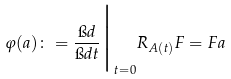Convert formula to latex. <formula><loc_0><loc_0><loc_500><loc_500>\varphi ( a ) \colon = \frac { \i d } { \i d t } \Big | _ { t = 0 } R _ { A ( t ) } F = F a</formula> 